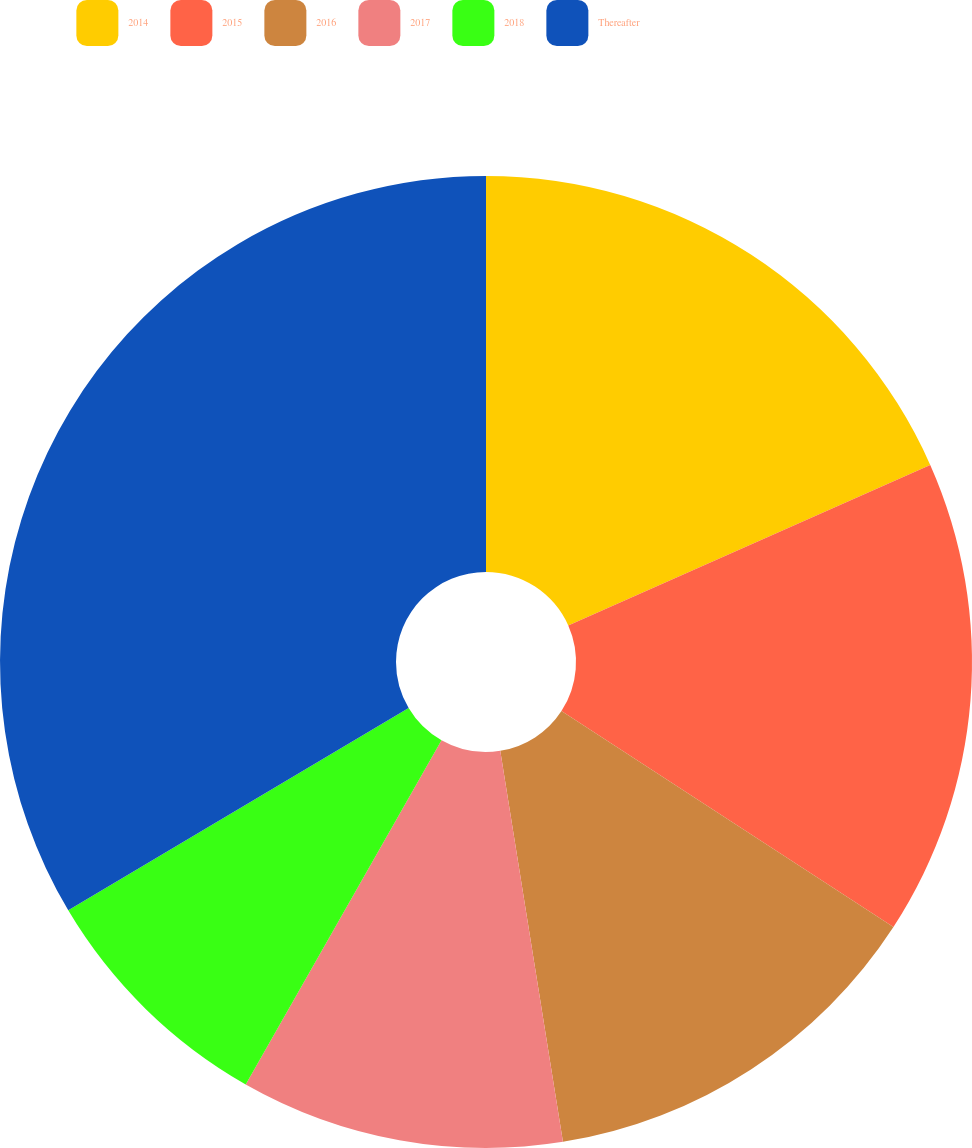Convert chart to OTSL. <chart><loc_0><loc_0><loc_500><loc_500><pie_chart><fcel>2014<fcel>2015<fcel>2016<fcel>2017<fcel>2018<fcel>Thereafter<nl><fcel>18.35%<fcel>15.82%<fcel>13.29%<fcel>10.76%<fcel>8.23%<fcel>33.53%<nl></chart> 